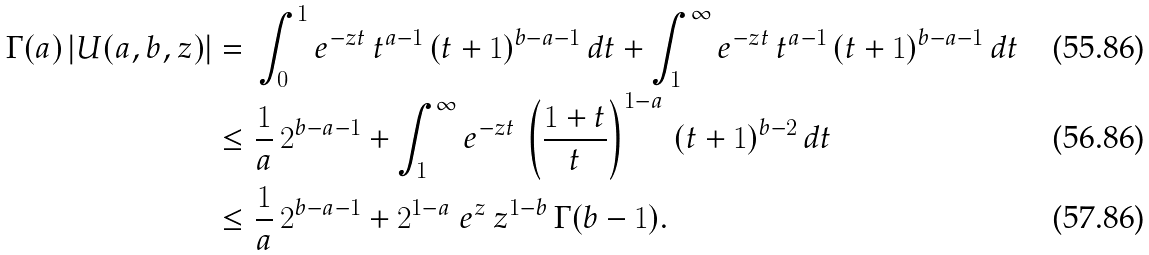<formula> <loc_0><loc_0><loc_500><loc_500>\Gamma ( a ) \, | U ( a , b , z ) | & = \, \int _ { 0 } ^ { 1 } e ^ { - z t } \, t ^ { a - 1 } \, ( t + 1 ) ^ { b - a - 1 } \, d t + \int _ { 1 } ^ { \infty } e ^ { - z t } \, t ^ { a - 1 } \, ( t + 1 ) ^ { b - a - 1 } \, d t \\ & \leq \frac { 1 } { a } \, 2 ^ { b - a - 1 } + \int _ { 1 } ^ { \infty } e ^ { - z t } \, \left ( \frac { 1 + t } { t } \right ) ^ { 1 - a } \, ( t + 1 ) ^ { b - 2 } \, d t \\ & \leq \frac { 1 } { a } \, 2 ^ { b - a - 1 } + 2 ^ { 1 - a } \ e ^ { z } \, z ^ { 1 - b } \, \Gamma ( b - 1 ) .</formula> 